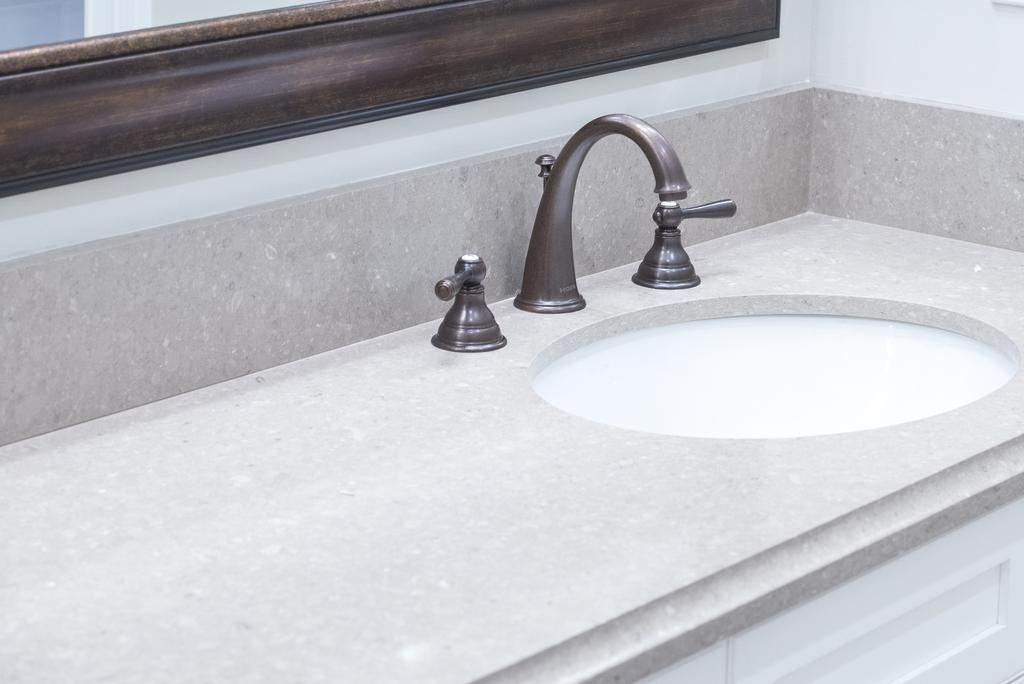Describe this image in one or two sentences. In this picture we can see a tap, sink and a wooden object in the background. We can see two spouts on both sides of a tap. 